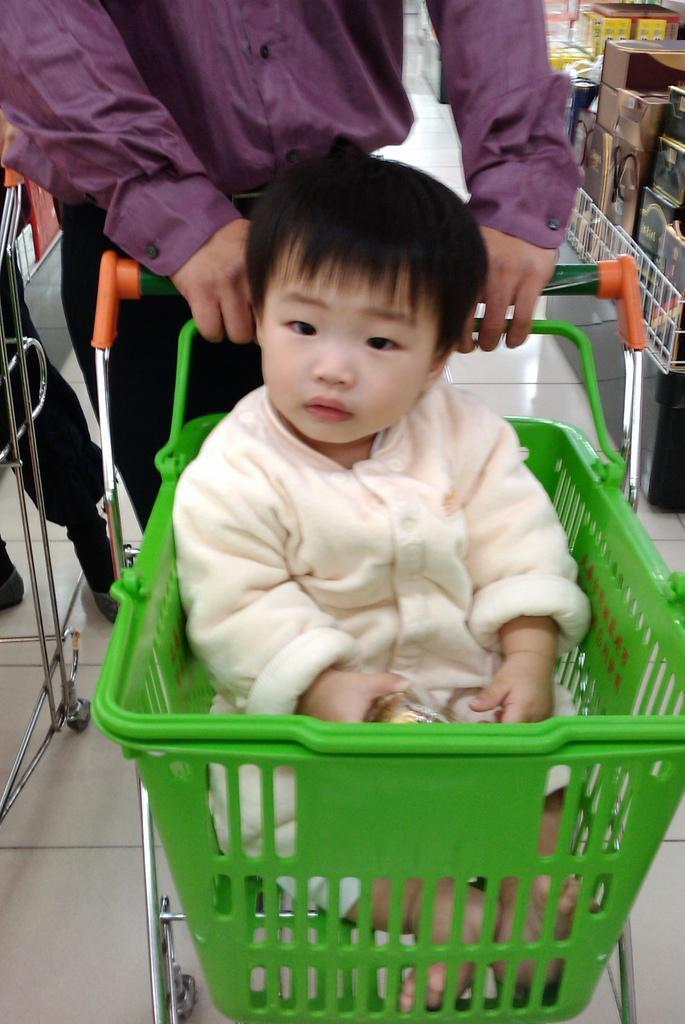In one or two sentences, can you explain what this image depicts? In this image I see a man who is holding this trolley and I see a baby who is sitting and I see the floor and I see that this man is wearing purple color shirt and I see number of groceries over here and I see a person's legs over here. 